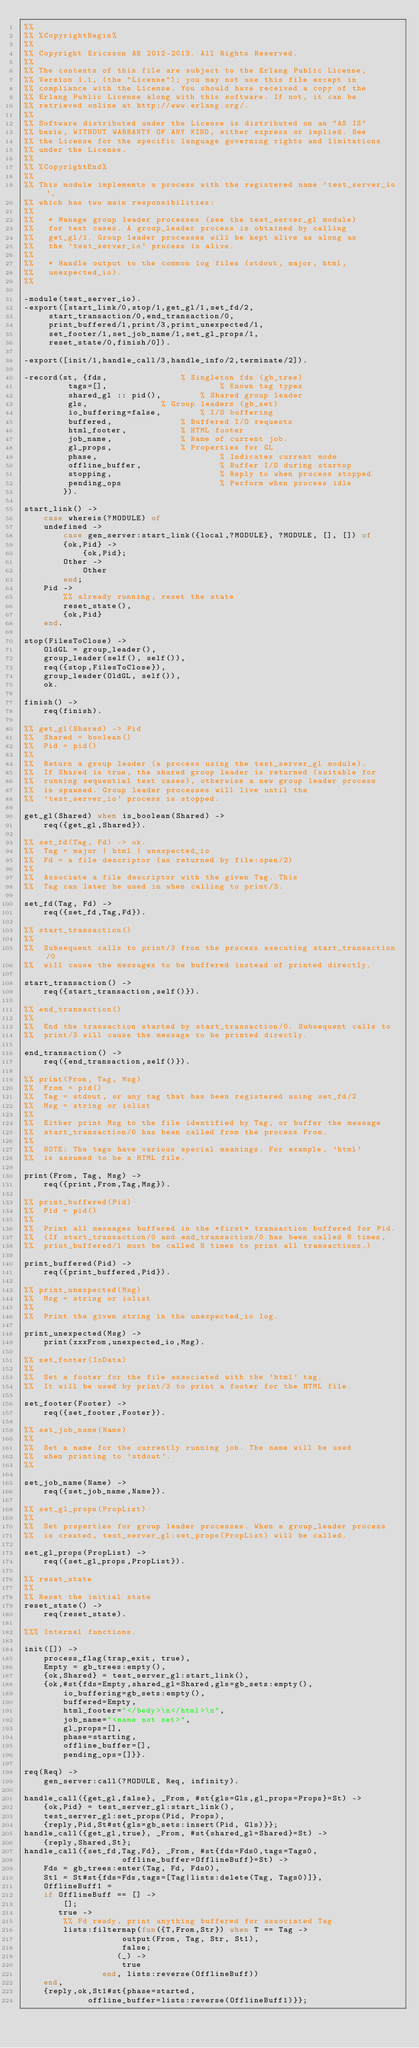<code> <loc_0><loc_0><loc_500><loc_500><_Erlang_>%%
%% %CopyrightBegin%
%%
%% Copyright Ericsson AB 2012-2013. All Rights Reserved.
%%
%% The contents of this file are subject to the Erlang Public License,
%% Version 1.1, (the "License"); you may not use this file except in
%% compliance with the License. You should have received a copy of the
%% Erlang Public License along with this software. If not, it can be
%% retrieved online at http://www.erlang.org/.
%%
%% Software distributed under the License is distributed on an "AS IS"
%% basis, WITHOUT WARRANTY OF ANY KIND, either express or implied. See
%% the License for the specific language governing rights and limitations
%% under the License.
%%
%% %CopyrightEnd%
%%
%% This module implements a process with the registered name 'test_server_io',
%% which has two main responsibilities:
%%
%%   * Manage group leader processes (see the test_server_gl module)
%%   for test cases. A group_leader process is obtained by calling
%%   get_gl/1. Group leader processes will be kept alive as along as
%%   the 'test_server_io' process is alive.
%%
%%   * Handle output to the common log files (stdout, major, html,
%%   unexpected_io).
%%

-module(test_server_io).
-export([start_link/0,stop/1,get_gl/1,set_fd/2,
	 start_transaction/0,end_transaction/0,
	 print_buffered/1,print/3,print_unexpected/1,
	 set_footer/1,set_job_name/1,set_gl_props/1,
	 reset_state/0,finish/0]).

-export([init/1,handle_call/3,handle_info/2,terminate/2]).

-record(st, {fds,			    % Singleton fds (gb_tree)
	     tags=[],                       % Known tag types   
	     shared_gl :: pid(),	    % Shared group leader
	     gls,			    % Group leaders (gb_set)
	     io_buffering=false,	    % I/O buffering
	     buffered,			    % Buffered I/O requests
	     html_footer,		    % HTML footer
	     job_name,			    % Name of current job.
	     gl_props,			    % Properties for GL
	     phase,                         % Indicates current mode
	     offline_buffer,                % Buffer I/O during startup
	     stopping,                      % Reply to when process stopped
	     pending_ops                    % Perform when process idle 
	    }).

start_link() ->
    case whereis(?MODULE) of
	undefined ->
	    case gen_server:start_link({local,?MODULE}, ?MODULE, [], []) of
		{ok,Pid} ->
		    {ok,Pid};
		Other ->
		    Other
	    end;
	Pid ->
	    %% already running, reset the state
	    reset_state(),
	    {ok,Pid}
    end.

stop(FilesToClose) ->
    OldGL = group_leader(),
    group_leader(self(), self()),
    req({stop,FilesToClose}),
    group_leader(OldGL, self()),
    ok.

finish() ->
    req(finish).

%% get_gl(Shared) -> Pid
%%  Shared = boolean()
%%  Pid = pid()
%%
%%  Return a group leader (a process using the test_server_gl module).
%%  If Shared is true, the shared group leader is returned (suitable for
%%  running sequential test cases), otherwise a new group leader process
%%  is spawned. Group leader processes will live until the
%%  'test_server_io' process is stopped.

get_gl(Shared) when is_boolean(Shared) ->
    req({get_gl,Shared}).

%% set_fd(Tag, Fd) -> ok.
%%  Tag = major | html | unexpected_io
%%  Fd = a file descriptor (as returned by file:open/2)
%%
%%  Associate a file descriptor with the given Tag. This
%%  Tag can later be used in when calling to print/3.

set_fd(Tag, Fd) ->
    req({set_fd,Tag,Fd}).

%% start_transaction()
%%
%%  Subsequent calls to print/3 from the process executing start_transaction/0
%%  will cause the messages to be buffered instead of printed directly.

start_transaction() ->
    req({start_transaction,self()}).

%% end_transaction()
%%
%%  End the transaction started by start_transaction/0. Subsequent calls to
%%  print/3 will cause the message to be printed directly.

end_transaction() ->
    req({end_transaction,self()}).

%% print(From, Tag, Msg)
%%  From = pid()
%%  Tag = stdout, or any tag that has been registered using set_fd/2
%%  Msg = string or iolist
%%
%%  Either print Msg to the file identified by Tag, or buffer the message
%%  start_transaction/0 has been called from the process From.
%%
%%  NOTE: The tags have various special meanings. For example, 'html'
%%  is assumed to be a HTML file.

print(From, Tag, Msg) ->
    req({print,From,Tag,Msg}).

%% print_buffered(Pid)
%%  Pid = pid()
%%
%%  Print all messages buffered in the *first* transaction buffered for Pid.
%%  (If start_transaction/0 and end_transaction/0 has been called N times,
%%  print_buffered/1 must be called N times to print all transactions.)

print_buffered(Pid) ->
    req({print_buffered,Pid}).

%% print_unexpected(Msg)
%%  Msg = string or iolist
%%
%%  Print the given string in the unexpected_io log.

print_unexpected(Msg) ->
    print(xxxFrom,unexpected_io,Msg).

%% set_footer(IoData)
%%
%%  Set a footer for the file associated with the 'html' tag.
%%  It will be used by print/3 to print a footer for the HTML file.

set_footer(Footer) ->
    req({set_footer,Footer}).

%% set_job_name(Name)
%%
%%  Set a name for the currently running job. The name will be used
%%  when printing to 'stdout'.
%%

set_job_name(Name) ->
    req({set_job_name,Name}).

%% set_gl_props(PropList)
%%
%%  Set properties for group leader processes. When a group_leader process
%%  is created, test_server_gl:set_props(PropList) will be called.

set_gl_props(PropList) ->
    req({set_gl_props,PropList}).

%% reset_state
%%
%% Reset the initial state
reset_state() ->
    req(reset_state).

%%% Internal functions.

init([]) ->
    process_flag(trap_exit, true),
    Empty = gb_trees:empty(),
    {ok,Shared} = test_server_gl:start_link(),
    {ok,#st{fds=Empty,shared_gl=Shared,gls=gb_sets:empty(),
	    io_buffering=gb_sets:empty(),
	    buffered=Empty,
	    html_footer="</body>\n</html>\n",
	    job_name="<name not set>",
	    gl_props=[],
	    phase=starting,
	    offline_buffer=[],
	    pending_ops=[]}}.

req(Req) ->
    gen_server:call(?MODULE, Req, infinity).

handle_call({get_gl,false}, _From, #st{gls=Gls,gl_props=Props}=St) ->
    {ok,Pid} = test_server_gl:start_link(),
    test_server_gl:set_props(Pid, Props),
    {reply,Pid,St#st{gls=gb_sets:insert(Pid, Gls)}};
handle_call({get_gl,true}, _From, #st{shared_gl=Shared}=St) ->
    {reply,Shared,St};
handle_call({set_fd,Tag,Fd}, _From, #st{fds=Fds0,tags=Tags0,
					offline_buffer=OfflineBuff}=St) ->
    Fds = gb_trees:enter(Tag, Fd, Fds0),
    St1 = St#st{fds=Fds,tags=[Tag|lists:delete(Tag, Tags0)]},
    OfflineBuff1 =
	if OfflineBuff == [] ->
		[];
	   true ->
		%% Fd ready, print anything buffered for associated Tag
		lists:filtermap(fun({T,From,Str}) when T == Tag ->
					output(From, Tag, Str, St1),
					false;
				   (_) ->
					true
				end, lists:reverse(OfflineBuff))
	end,
    {reply,ok,St1#st{phase=started,
		     offline_buffer=lists:reverse(OfflineBuff1)}};</code> 